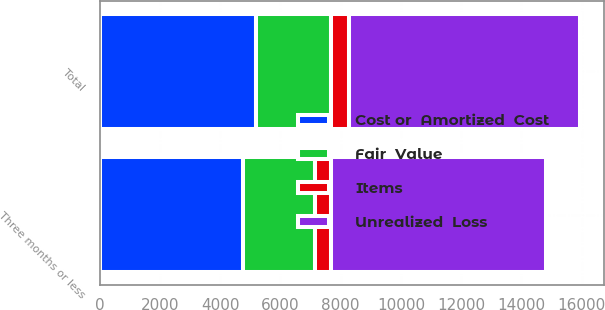<chart> <loc_0><loc_0><loc_500><loc_500><stacked_bar_chart><ecel><fcel>Three months or less<fcel>Total<nl><fcel>Items<fcel>532<fcel>590<nl><fcel>Unrealized  Loss<fcel>7150<fcel>7679<nl><fcel>Fair  Value<fcel>2395<fcel>2477<nl><fcel>Cost or  Amortized  Cost<fcel>4755<fcel>5202<nl></chart> 